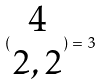<formula> <loc_0><loc_0><loc_500><loc_500>( \begin{matrix} 4 \\ 2 , 2 \end{matrix} ) = 3</formula> 